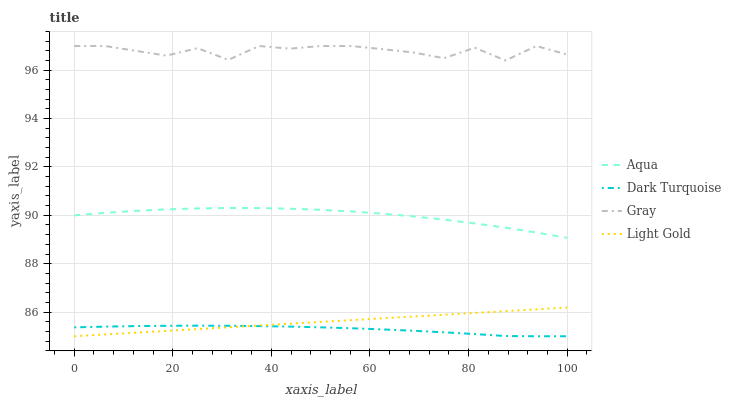Does Dark Turquoise have the minimum area under the curve?
Answer yes or no. Yes. Does Gray have the maximum area under the curve?
Answer yes or no. Yes. Does Light Gold have the minimum area under the curve?
Answer yes or no. No. Does Light Gold have the maximum area under the curve?
Answer yes or no. No. Is Light Gold the smoothest?
Answer yes or no. Yes. Is Gray the roughest?
Answer yes or no. Yes. Is Aqua the smoothest?
Answer yes or no. No. Is Aqua the roughest?
Answer yes or no. No. Does Dark Turquoise have the lowest value?
Answer yes or no. Yes. Does Aqua have the lowest value?
Answer yes or no. No. Does Gray have the highest value?
Answer yes or no. Yes. Does Light Gold have the highest value?
Answer yes or no. No. Is Dark Turquoise less than Gray?
Answer yes or no. Yes. Is Gray greater than Light Gold?
Answer yes or no. Yes. Does Dark Turquoise intersect Light Gold?
Answer yes or no. Yes. Is Dark Turquoise less than Light Gold?
Answer yes or no. No. Is Dark Turquoise greater than Light Gold?
Answer yes or no. No. Does Dark Turquoise intersect Gray?
Answer yes or no. No. 